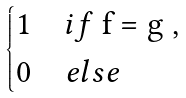<formula> <loc_0><loc_0><loc_500><loc_500>\begin{dcases} 1 & i f $ f = g $ , \\ 0 & e l s e \end{dcases}</formula> 